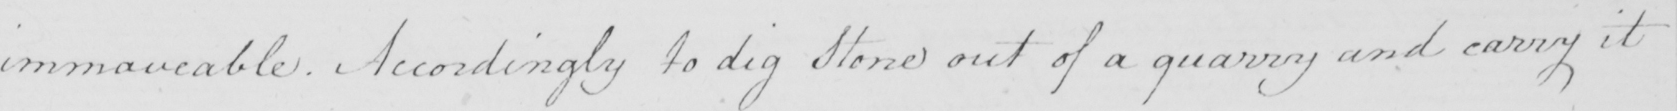What is written in this line of handwriting? immoveable . Accordingly to dig Stone out of a quarry and carry it 